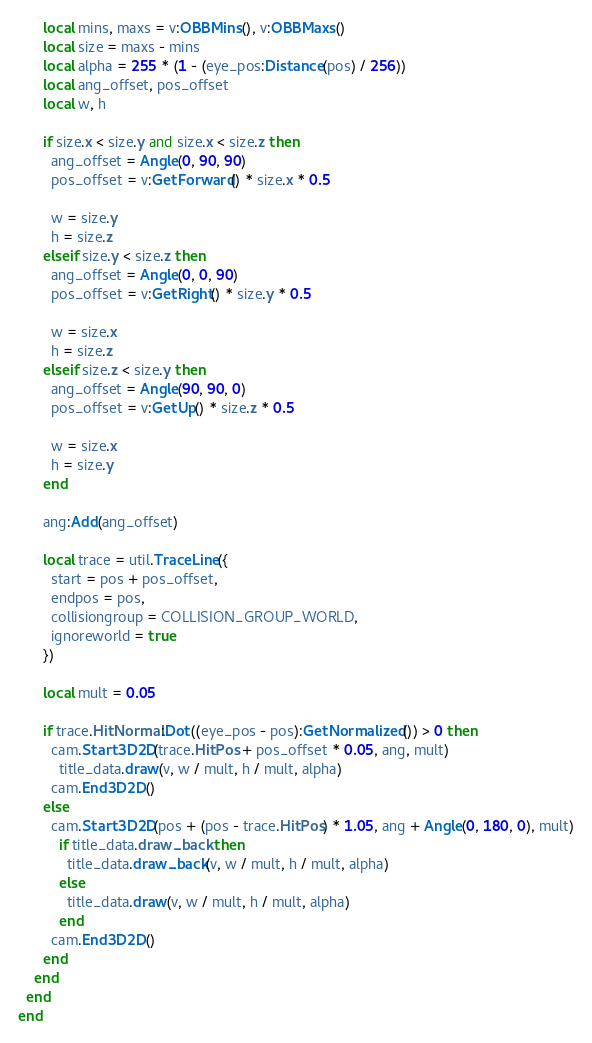<code> <loc_0><loc_0><loc_500><loc_500><_Lua_>      local mins, maxs = v:OBBMins(), v:OBBMaxs()
      local size = maxs - mins
      local alpha = 255 * (1 - (eye_pos:Distance(pos) / 256))
      local ang_offset, pos_offset
      local w, h

      if size.x < size.y and size.x < size.z then
        ang_offset = Angle(0, 90, 90)
        pos_offset = v:GetForward() * size.x * 0.5

        w = size.y
        h = size.z
      elseif size.y < size.z then
        ang_offset = Angle(0, 0, 90)
        pos_offset = v:GetRight() * size.y * 0.5

        w = size.x
        h = size.z
      elseif size.z < size.y then
        ang_offset = Angle(90, 90, 0)
        pos_offset = v:GetUp() * size.z * 0.5

        w = size.x
        h = size.y
      end

      ang:Add(ang_offset)

      local trace = util.TraceLine({
        start = pos + pos_offset,
        endpos = pos,
        collisiongroup = COLLISION_GROUP_WORLD,
        ignoreworld = true
      })

      local mult = 0.05

      if trace.HitNormal:Dot((eye_pos - pos):GetNormalized()) > 0 then
        cam.Start3D2D(trace.HitPos + pos_offset * 0.05, ang, mult)
          title_data.draw(v, w / mult, h / mult, alpha)
        cam.End3D2D()
      else
        cam.Start3D2D(pos + (pos - trace.HitPos) * 1.05, ang + Angle(0, 180, 0), mult)
          if title_data.draw_back then
            title_data.draw_back(v, w / mult, h / mult, alpha)
          else
            title_data.draw(v, w / mult, h / mult, alpha)
          end
        cam.End3D2D()
      end
    end
  end
end
</code> 